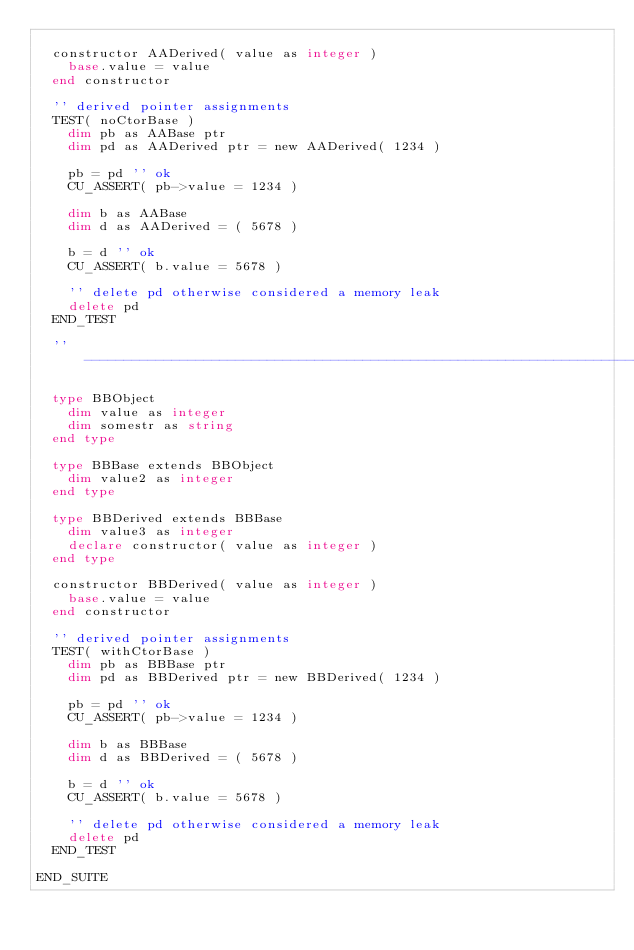<code> <loc_0><loc_0><loc_500><loc_500><_VisualBasic_>
	constructor AADerived( value as integer )
		base.value = value
	end constructor

	'' derived pointer assignments
	TEST( noCtorBase )
		dim pb as AABase ptr
		dim pd as AADerived ptr = new AADerived( 1234 )

		pb = pd '' ok
		CU_ASSERT( pb->value = 1234 )

		dim b as AABase
		dim d as AADerived = ( 5678 )

		b = d '' ok
		CU_ASSERT( b.value = 5678 )

		'' delete pd otherwise considered a memory leak
		delete pd
	END_TEST

	'' -------------------------------------------------------------------------

	type BBObject
		dim value as integer
		dim somestr as string
	end type

	type BBBase extends BBObject
		dim value2 as integer
	end type

	type BBDerived extends BBBase
		dim value3 as integer
		declare constructor( value as integer )
	end type

	constructor BBDerived( value as integer )
		base.value = value
	end constructor

	'' derived pointer assignments
	TEST( withCtorBase )
		dim pb as BBBase ptr
		dim pd as BBDerived ptr = new BBDerived( 1234 )

		pb = pd '' ok
		CU_ASSERT( pb->value = 1234 )

		dim b as BBBase
		dim d as BBDerived = ( 5678 )

		b = d '' ok
		CU_ASSERT( b.value = 5678 )

		'' delete pd otherwise considered a memory leak
		delete pd
	END_TEST

END_SUITE
</code> 